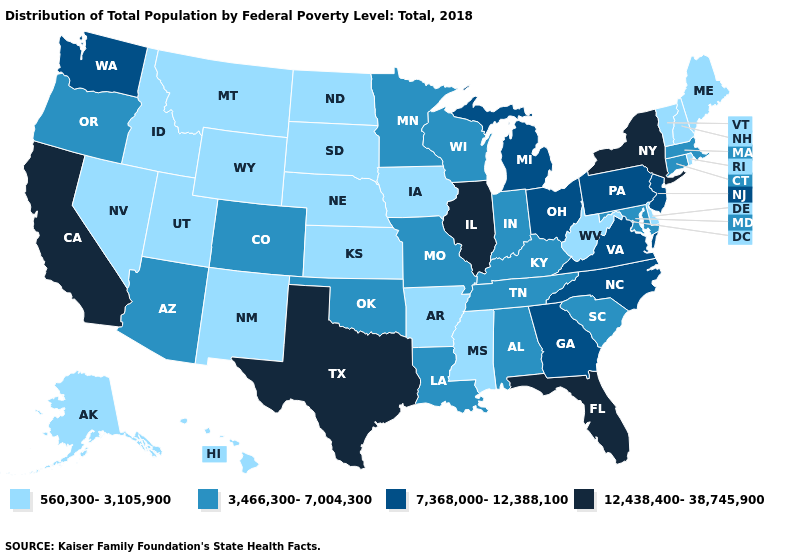What is the value of Nevada?
Be succinct. 560,300-3,105,900. Does Florida have a lower value than Rhode Island?
Write a very short answer. No. Name the states that have a value in the range 560,300-3,105,900?
Concise answer only. Alaska, Arkansas, Delaware, Hawaii, Idaho, Iowa, Kansas, Maine, Mississippi, Montana, Nebraska, Nevada, New Hampshire, New Mexico, North Dakota, Rhode Island, South Dakota, Utah, Vermont, West Virginia, Wyoming. Among the states that border Wyoming , does Idaho have the lowest value?
Be succinct. Yes. What is the highest value in states that border West Virginia?
Answer briefly. 7,368,000-12,388,100. Name the states that have a value in the range 3,466,300-7,004,300?
Give a very brief answer. Alabama, Arizona, Colorado, Connecticut, Indiana, Kentucky, Louisiana, Maryland, Massachusetts, Minnesota, Missouri, Oklahoma, Oregon, South Carolina, Tennessee, Wisconsin. What is the value of Ohio?
Keep it brief. 7,368,000-12,388,100. Which states hav the highest value in the West?
Quick response, please. California. Name the states that have a value in the range 7,368,000-12,388,100?
Write a very short answer. Georgia, Michigan, New Jersey, North Carolina, Ohio, Pennsylvania, Virginia, Washington. Does Virginia have the same value as Wyoming?
Keep it brief. No. What is the value of Vermont?
Keep it brief. 560,300-3,105,900. Name the states that have a value in the range 12,438,400-38,745,900?
Keep it brief. California, Florida, Illinois, New York, Texas. What is the value of Georgia?
Give a very brief answer. 7,368,000-12,388,100. What is the value of South Carolina?
Concise answer only. 3,466,300-7,004,300. Does Pennsylvania have a lower value than Texas?
Give a very brief answer. Yes. 